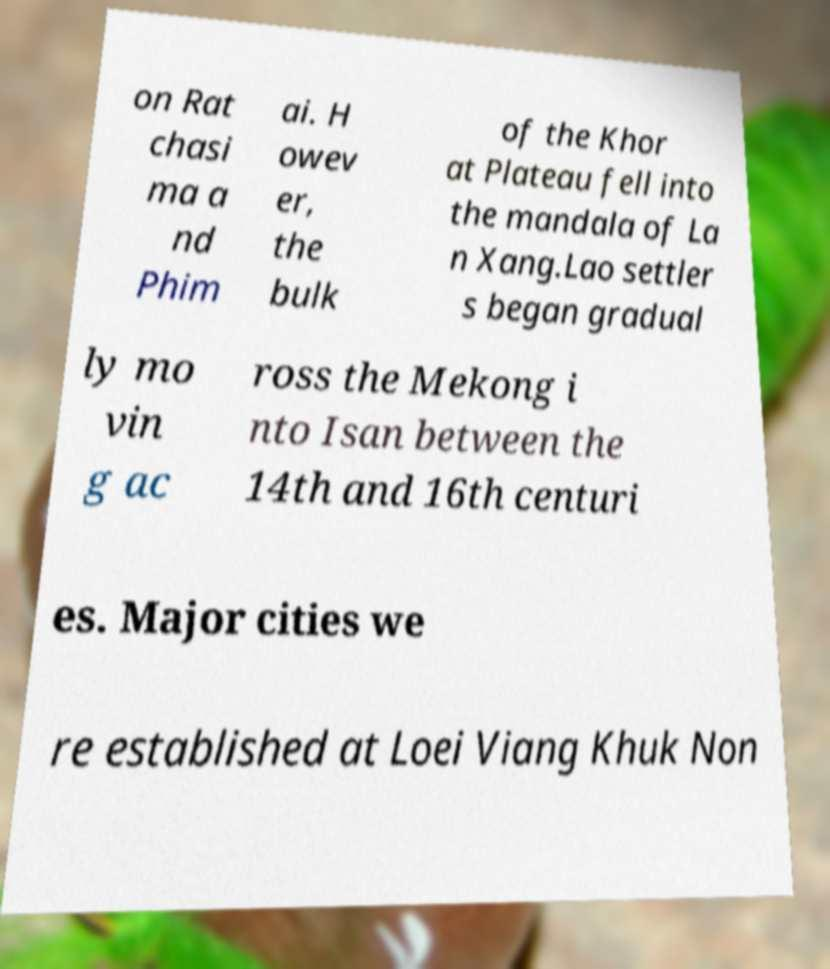For documentation purposes, I need the text within this image transcribed. Could you provide that? on Rat chasi ma a nd Phim ai. H owev er, the bulk of the Khor at Plateau fell into the mandala of La n Xang.Lao settler s began gradual ly mo vin g ac ross the Mekong i nto Isan between the 14th and 16th centuri es. Major cities we re established at Loei Viang Khuk Non 